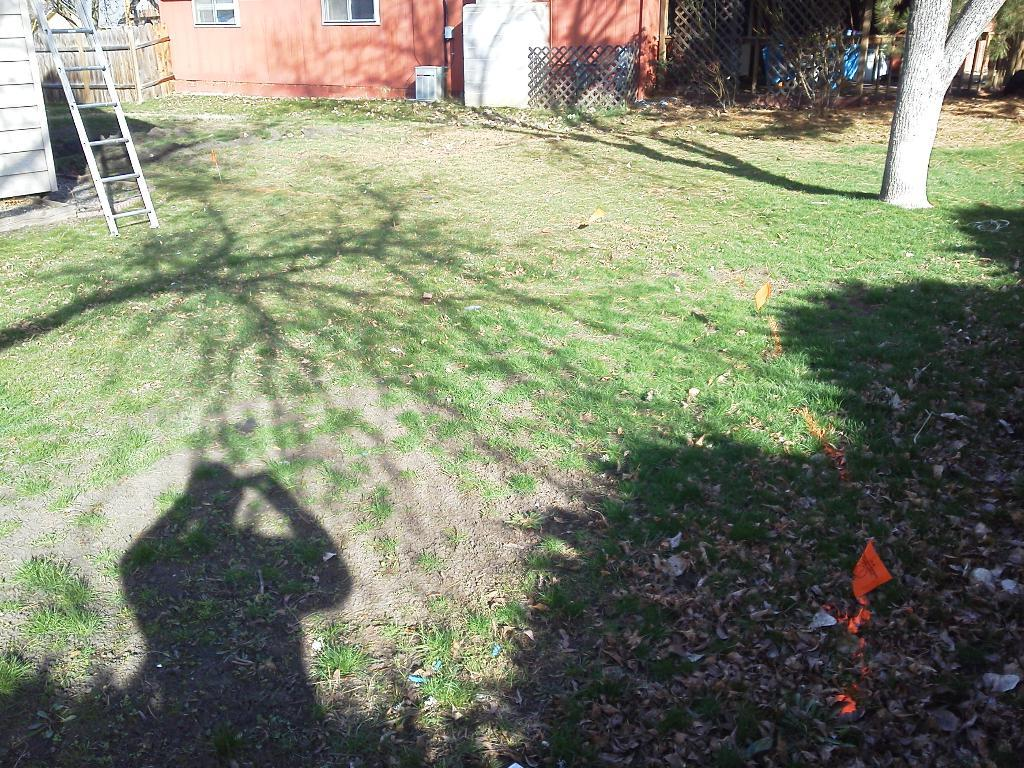What type of structure is visible in the image? There is a building in the image. What can be seen in the background of the image? There are trees in the background of the image. Where is the ladder located in the image? The ladder is on the left side of the image. What type of vegetation is present on the ground in the image? Grass is present on the ground in the image. What type of note is the doll holding in the image? There is no doll or note present in the image. 